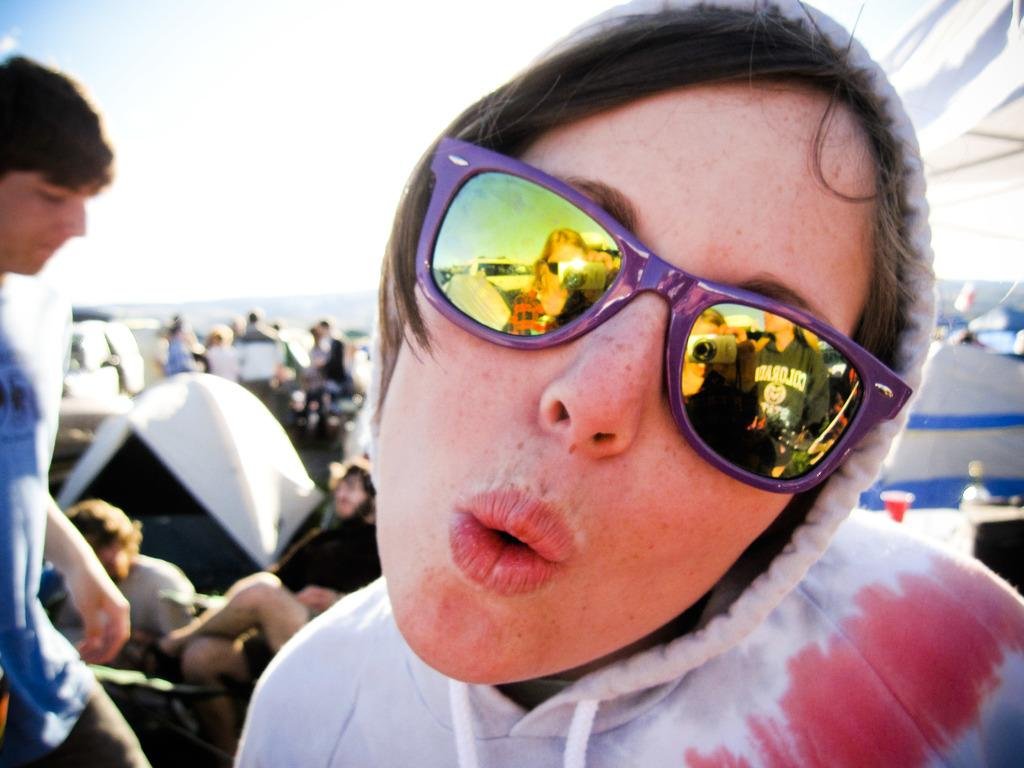What is the main subject of the image? There is a person in the image. Can you describe the person's clothing? The person is wearing a hoodie. What accessory is the person wearing? The person is wearing glasses. What can be seen in the background of the image? There are people and objects on the ground in the background of the image, as well as the sky. What type of wilderness can be seen in the image? There is no wilderness present in the image; it features a person in the foreground and people and objects in the background. Can you describe the trail that the person is walking on in the image? There is no trail visible in the image; it only shows a person in the foreground and people and objects in the background. 